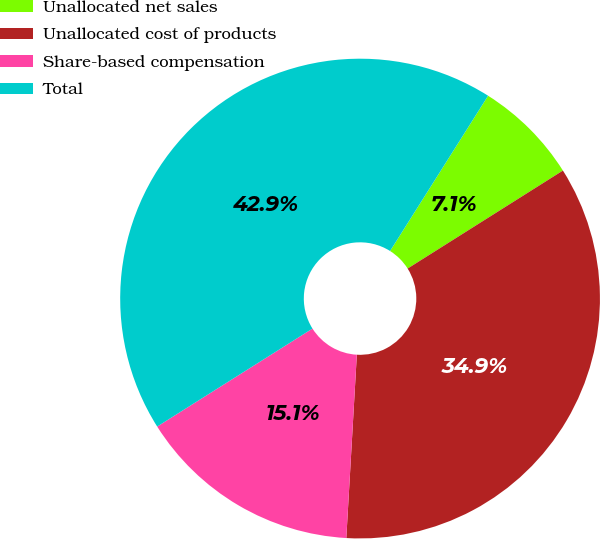<chart> <loc_0><loc_0><loc_500><loc_500><pie_chart><fcel>Unallocated net sales<fcel>Unallocated cost of products<fcel>Share-based compensation<fcel>Total<nl><fcel>7.08%<fcel>34.87%<fcel>15.13%<fcel>42.92%<nl></chart> 